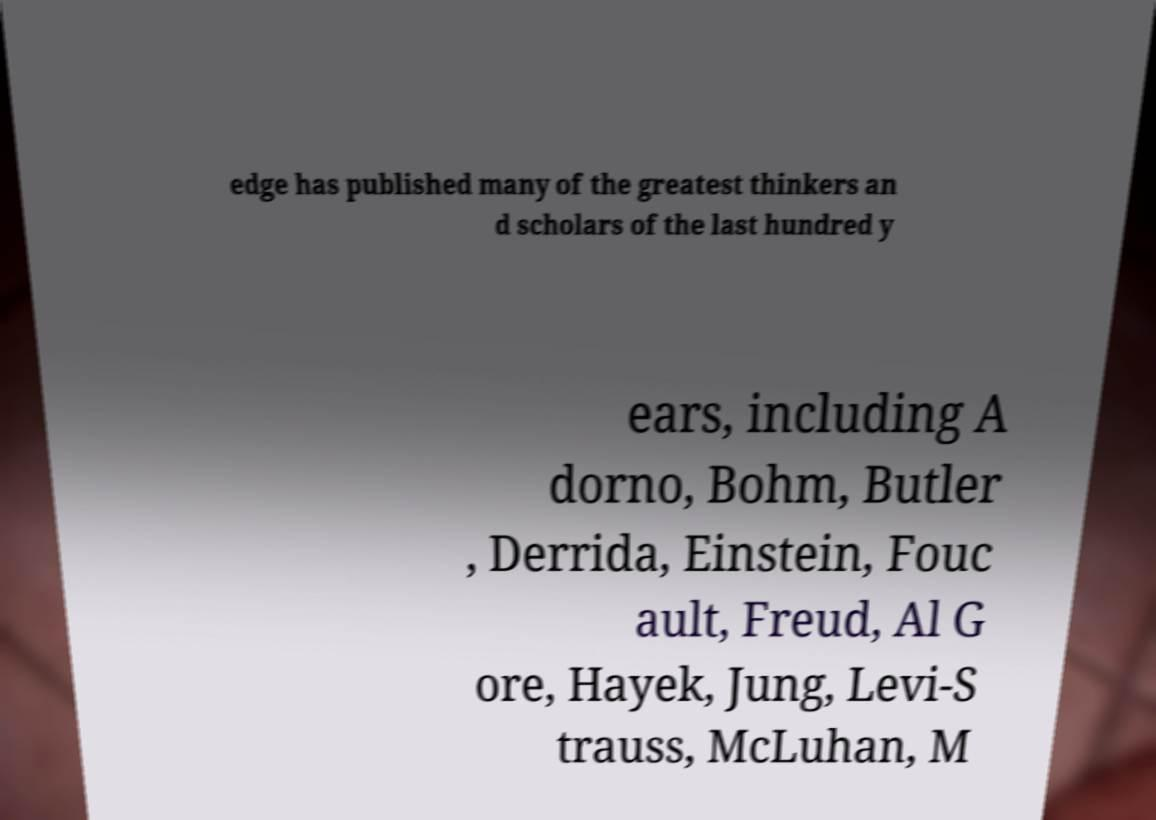I need the written content from this picture converted into text. Can you do that? edge has published many of the greatest thinkers an d scholars of the last hundred y ears, including A dorno, Bohm, Butler , Derrida, Einstein, Fouc ault, Freud, Al G ore, Hayek, Jung, Levi-S trauss, McLuhan, M 